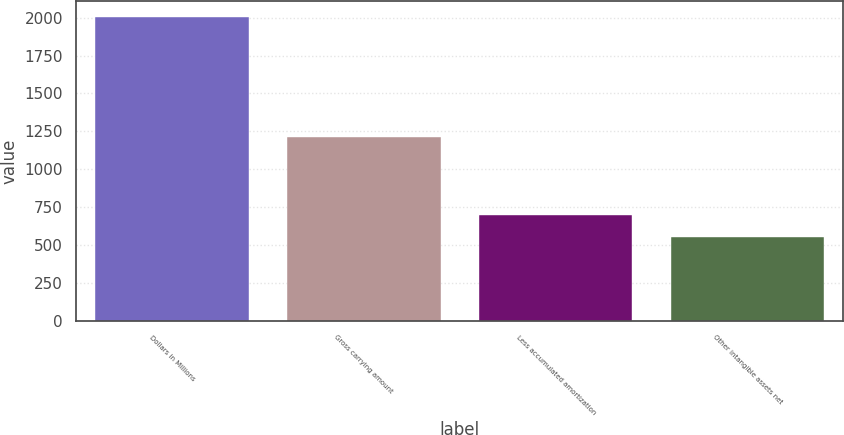<chart> <loc_0><loc_0><loc_500><loc_500><bar_chart><fcel>Dollars in Millions<fcel>Gross carrying amount<fcel>Less accumulated amortization<fcel>Other intangible assets net<nl><fcel>2007<fcel>1214<fcel>699.3<fcel>554<nl></chart> 